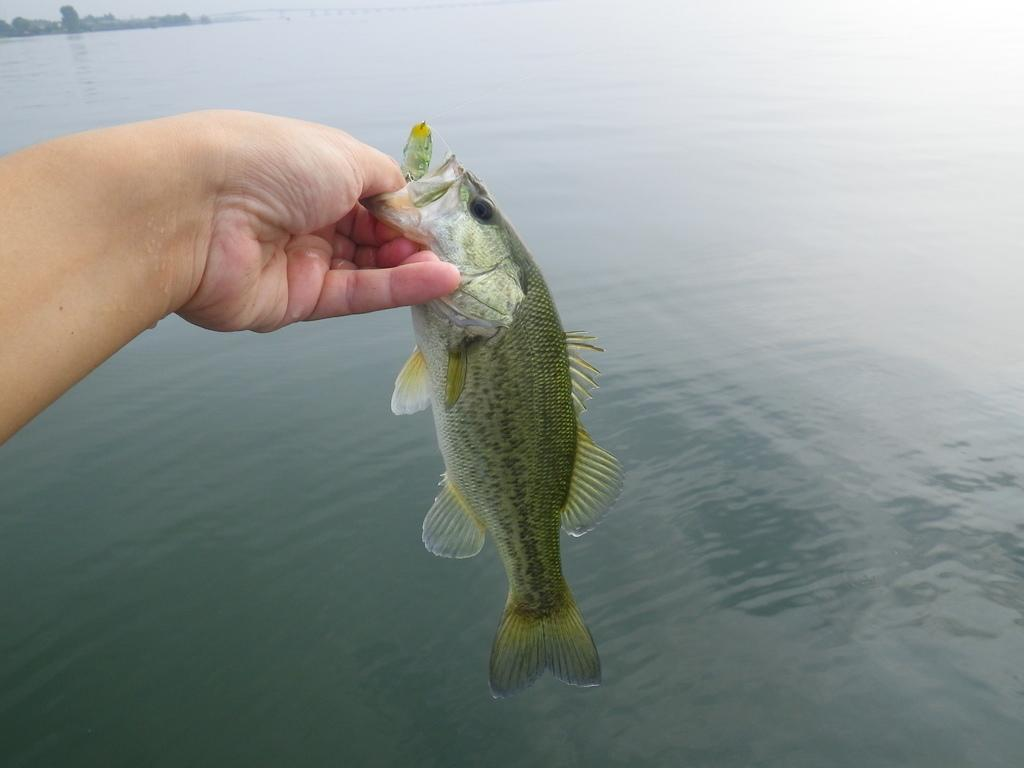What is the hand holding in the image? The hand is holding a fish in the image. What part of the hand can be seen in the image? The fingers of the hand are visible in the image. What is the fish positioned above in the image? There is a water surface under the fish in the image. What arithmetic problem is being solved by the fish in the image? There is no arithmetic problem being solved by the fish in the image; it is simply being held by a hand. What type of drum can be seen in the image? There is no drum present in the image. 